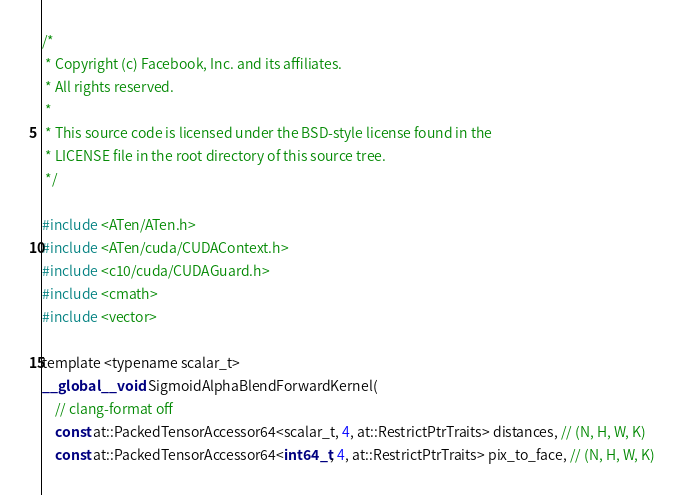<code> <loc_0><loc_0><loc_500><loc_500><_Cuda_>/*
 * Copyright (c) Facebook, Inc. and its affiliates.
 * All rights reserved.
 *
 * This source code is licensed under the BSD-style license found in the
 * LICENSE file in the root directory of this source tree.
 */

#include <ATen/ATen.h>
#include <ATen/cuda/CUDAContext.h>
#include <c10/cuda/CUDAGuard.h>
#include <cmath>
#include <vector>

template <typename scalar_t>
__global__ void SigmoidAlphaBlendForwardKernel(
    // clang-format off
    const at::PackedTensorAccessor64<scalar_t, 4, at::RestrictPtrTraits> distances, // (N, H, W, K)
    const at::PackedTensorAccessor64<int64_t, 4, at::RestrictPtrTraits> pix_to_face, // (N, H, W, K)</code> 